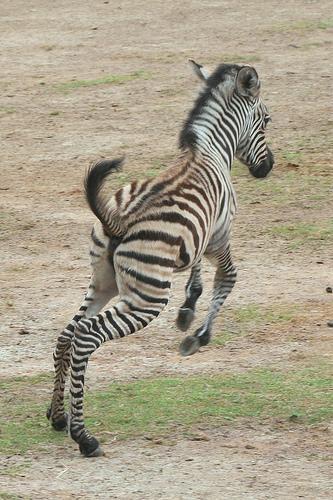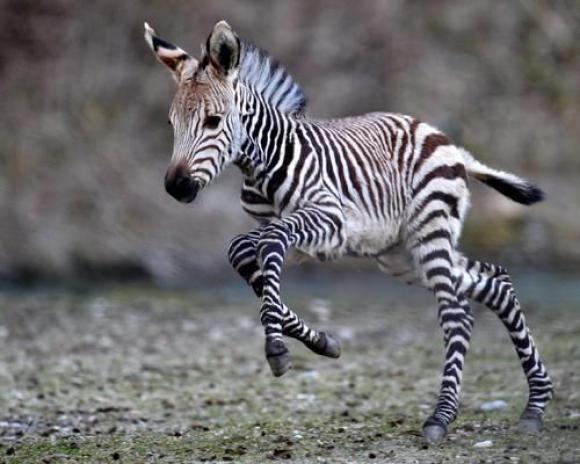The first image is the image on the left, the second image is the image on the right. Considering the images on both sides, is "Two zebras play with each other in a field in each of the images." valid? Answer yes or no. No. The first image is the image on the left, the second image is the image on the right. Evaluate the accuracy of this statement regarding the images: "The right image contains exactly two zebras.". Is it true? Answer yes or no. No. 